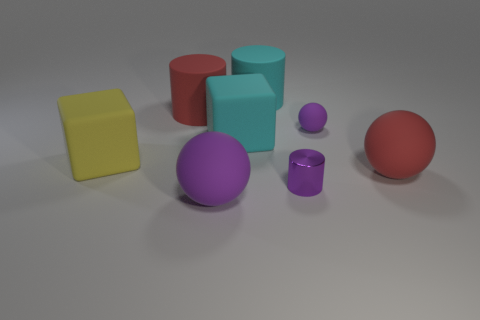Add 1 tiny purple objects. How many objects exist? 9 Subtract all cylinders. How many objects are left? 5 Add 3 small matte things. How many small matte things are left? 4 Add 8 big cyan cubes. How many big cyan cubes exist? 9 Subtract 0 purple blocks. How many objects are left? 8 Subtract all small brown matte cylinders. Subtract all cylinders. How many objects are left? 5 